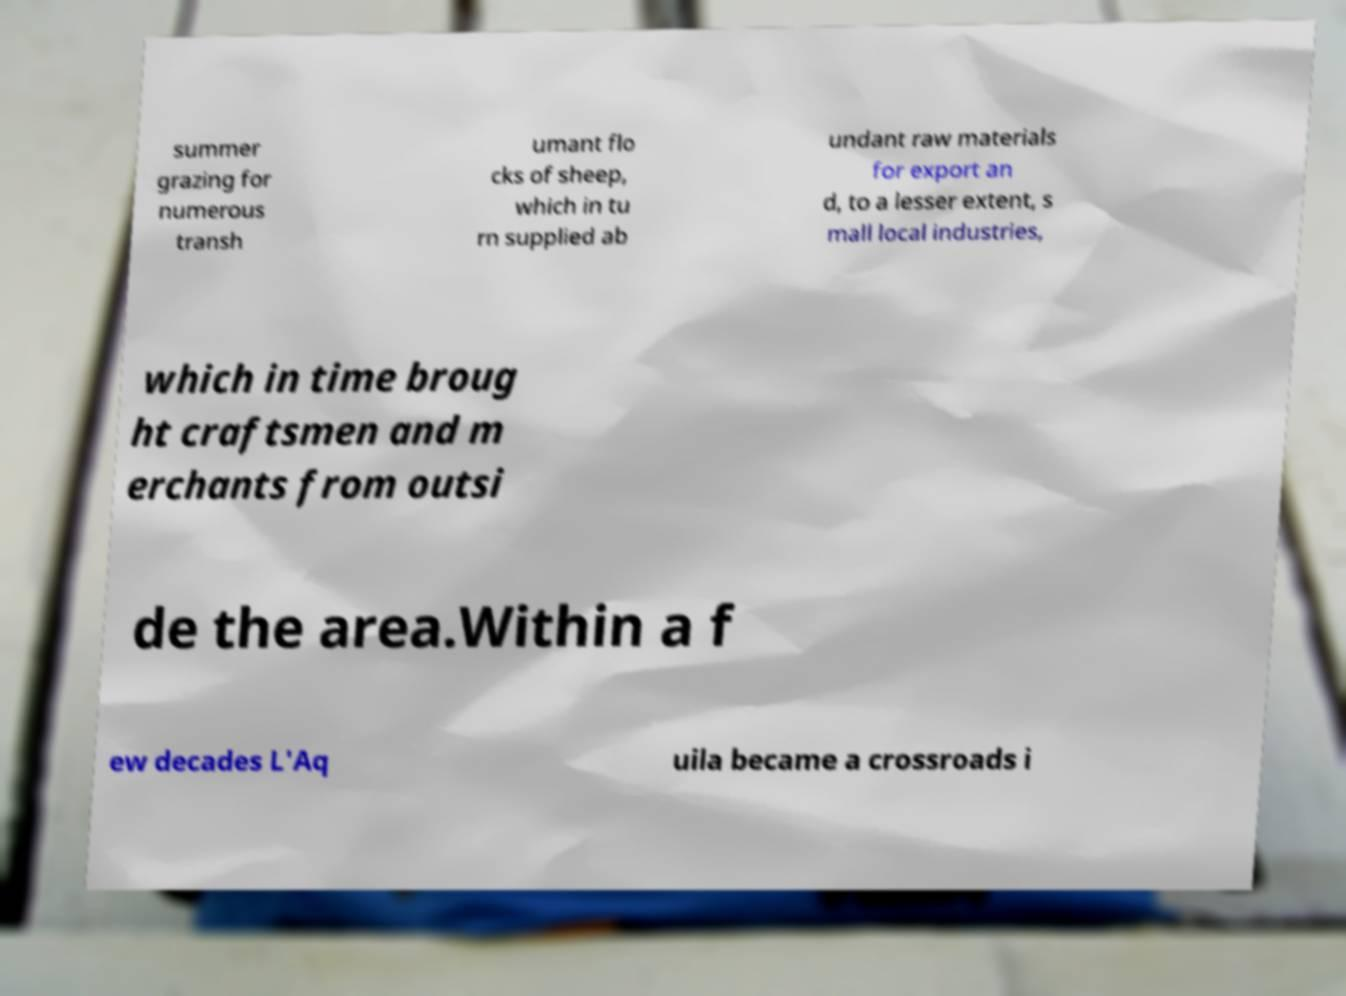There's text embedded in this image that I need extracted. Can you transcribe it verbatim? summer grazing for numerous transh umant flo cks of sheep, which in tu rn supplied ab undant raw materials for export an d, to a lesser extent, s mall local industries, which in time broug ht craftsmen and m erchants from outsi de the area.Within a f ew decades L'Aq uila became a crossroads i 